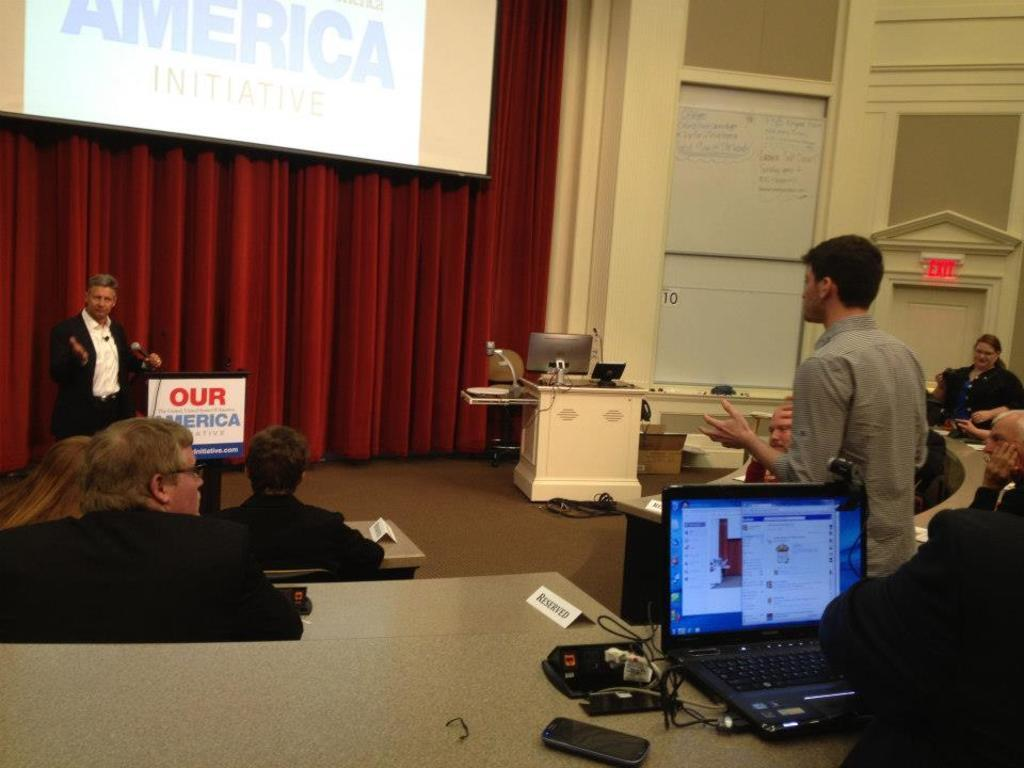<image>
Provide a brief description of the given image. A man giving a speech behind a podium that says, "Our America." 